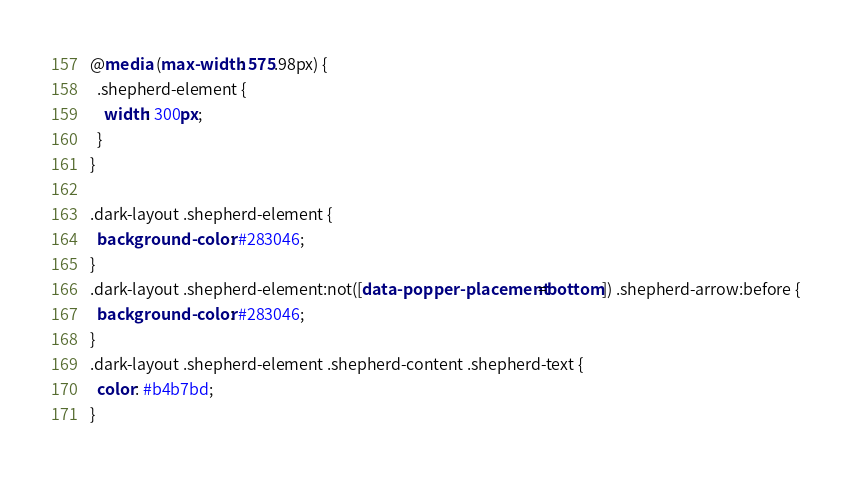<code> <loc_0><loc_0><loc_500><loc_500><_CSS_>@media (max-width: 575.98px) {
  .shepherd-element {
    width: 300px;
  }
}

.dark-layout .shepherd-element {
  background-color: #283046;
}
.dark-layout .shepherd-element:not([data-popper-placement=bottom]) .shepherd-arrow:before {
  background-color: #283046;
}
.dark-layout .shepherd-element .shepherd-content .shepherd-text {
  color: #b4b7bd;
}
</code> 